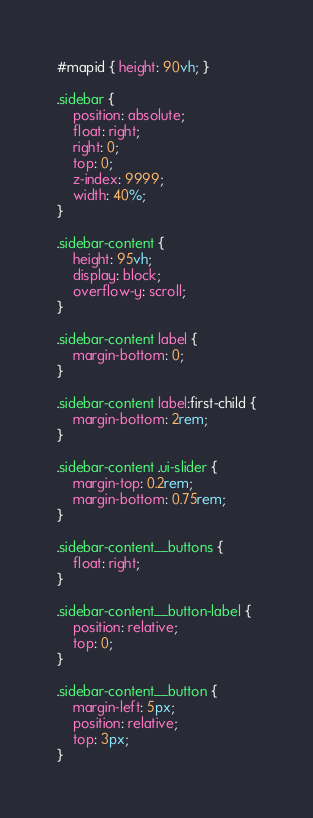Convert code to text. <code><loc_0><loc_0><loc_500><loc_500><_CSS_>#mapid { height: 90vh; }

.sidebar {
    position: absolute;
	float: right;
    right: 0;
    top: 0;
    z-index: 9999;
    width: 40%;
}

.sidebar-content {
    height: 95vh;
    display: block;
    overflow-y: scroll;
}

.sidebar-content label {
    margin-bottom: 0;
}

.sidebar-content label:first-child {
    margin-bottom: 2rem;
}

.sidebar-content .ui-slider {
    margin-top: 0.2rem;
    margin-bottom: 0.75rem;
}

.sidebar-content__buttons {
    float: right;
}

.sidebar-content__button-label {
    position: relative;
    top: 0;
}

.sidebar-content__button {
    margin-left: 5px;
    position: relative;
    top: 3px;
}</code> 